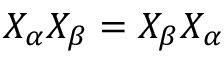Convert formula to latex. <formula><loc_0><loc_0><loc_500><loc_500>X _ { \alpha } X _ { \beta } = X _ { \beta } X _ { \alpha }</formula> 